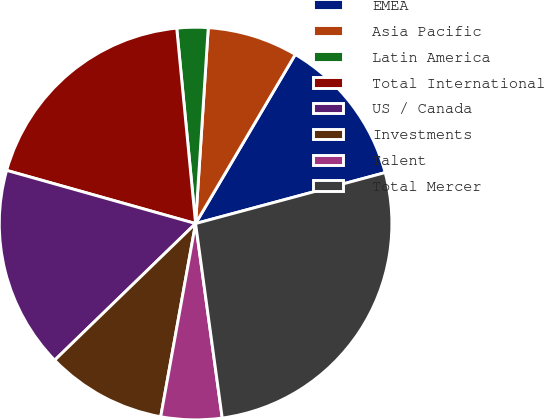Convert chart. <chart><loc_0><loc_0><loc_500><loc_500><pie_chart><fcel>EMEA<fcel>Asia Pacific<fcel>Latin America<fcel>Total International<fcel>US / Canada<fcel>Investments<fcel>Talent<fcel>Total Mercer<nl><fcel>12.34%<fcel>7.45%<fcel>2.56%<fcel>19.1%<fcel>16.62%<fcel>9.9%<fcel>5.01%<fcel>27.01%<nl></chart> 